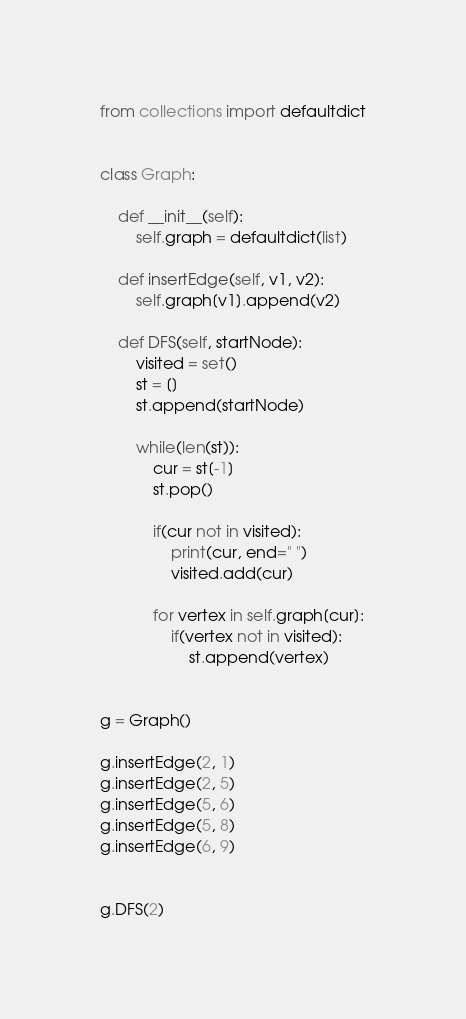<code> <loc_0><loc_0><loc_500><loc_500><_Python_>from collections import defaultdict


class Graph:

    def __init__(self):
        self.graph = defaultdict(list)

    def insertEdge(self, v1, v2):
        self.graph[v1].append(v2)

    def DFS(self, startNode):
        visited = set()
        st = []
        st.append(startNode)

        while(len(st)):
            cur = st[-1]
            st.pop()

            if(cur not in visited):
                print(cur, end=" ")
                visited.add(cur)

            for vertex in self.graph[cur]:
                if(vertex not in visited):
                    st.append(vertex)


g = Graph()

g.insertEdge(2, 1)
g.insertEdge(2, 5)
g.insertEdge(5, 6)
g.insertEdge(5, 8)
g.insertEdge(6, 9)


g.DFS(2)</code> 